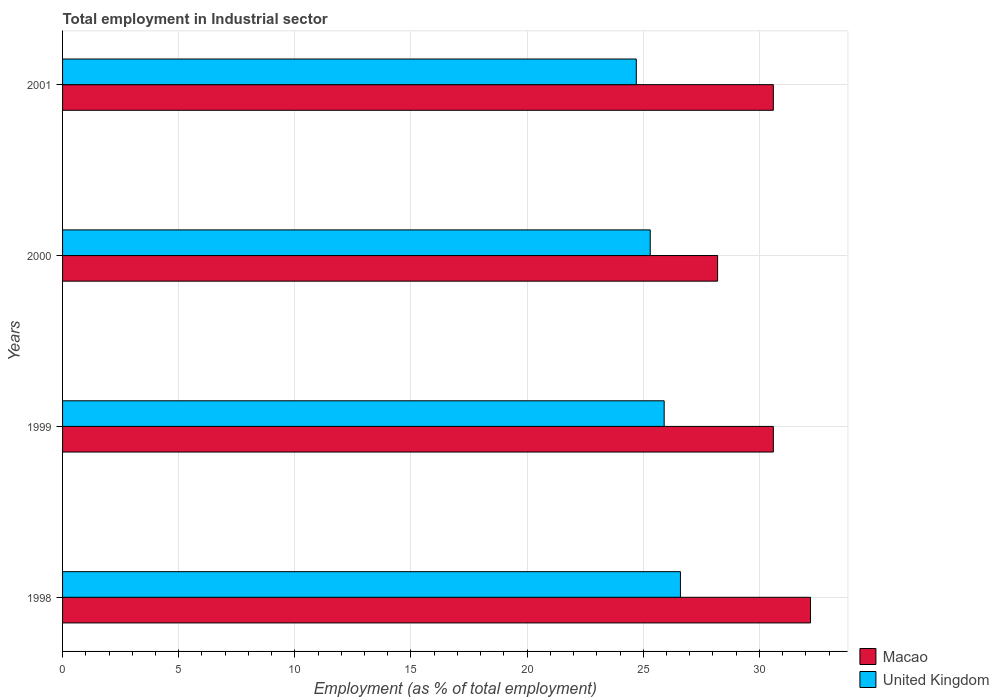Are the number of bars per tick equal to the number of legend labels?
Your answer should be compact. Yes. Are the number of bars on each tick of the Y-axis equal?
Provide a short and direct response. Yes. How many bars are there on the 1st tick from the top?
Your response must be concise. 2. What is the employment in industrial sector in United Kingdom in 1998?
Provide a short and direct response. 26.6. Across all years, what is the maximum employment in industrial sector in United Kingdom?
Your answer should be compact. 26.6. Across all years, what is the minimum employment in industrial sector in United Kingdom?
Your response must be concise. 24.7. In which year was the employment in industrial sector in United Kingdom minimum?
Ensure brevity in your answer.  2001. What is the total employment in industrial sector in United Kingdom in the graph?
Your answer should be very brief. 102.5. What is the difference between the employment in industrial sector in United Kingdom in 1998 and that in 2000?
Ensure brevity in your answer.  1.3. What is the average employment in industrial sector in United Kingdom per year?
Keep it short and to the point. 25.62. In the year 1998, what is the difference between the employment in industrial sector in Macao and employment in industrial sector in United Kingdom?
Keep it short and to the point. 5.6. In how many years, is the employment in industrial sector in Macao greater than 20 %?
Make the answer very short. 4. What is the ratio of the employment in industrial sector in Macao in 1999 to that in 2000?
Provide a short and direct response. 1.09. Is the difference between the employment in industrial sector in Macao in 2000 and 2001 greater than the difference between the employment in industrial sector in United Kingdom in 2000 and 2001?
Give a very brief answer. No. What is the difference between the highest and the second highest employment in industrial sector in United Kingdom?
Provide a short and direct response. 0.7. What is the difference between the highest and the lowest employment in industrial sector in Macao?
Give a very brief answer. 4. Is the sum of the employment in industrial sector in Macao in 1999 and 2001 greater than the maximum employment in industrial sector in United Kingdom across all years?
Ensure brevity in your answer.  Yes. What does the 1st bar from the top in 2001 represents?
Offer a very short reply. United Kingdom. What does the 1st bar from the bottom in 2000 represents?
Your answer should be very brief. Macao. How many bars are there?
Your answer should be very brief. 8. Are all the bars in the graph horizontal?
Offer a very short reply. Yes. What is the difference between two consecutive major ticks on the X-axis?
Offer a very short reply. 5. Are the values on the major ticks of X-axis written in scientific E-notation?
Offer a very short reply. No. What is the title of the graph?
Offer a very short reply. Total employment in Industrial sector. What is the label or title of the X-axis?
Provide a short and direct response. Employment (as % of total employment). What is the label or title of the Y-axis?
Provide a succinct answer. Years. What is the Employment (as % of total employment) of Macao in 1998?
Provide a short and direct response. 32.2. What is the Employment (as % of total employment) of United Kingdom in 1998?
Your answer should be very brief. 26.6. What is the Employment (as % of total employment) of Macao in 1999?
Give a very brief answer. 30.6. What is the Employment (as % of total employment) in United Kingdom in 1999?
Offer a terse response. 25.9. What is the Employment (as % of total employment) of Macao in 2000?
Provide a short and direct response. 28.2. What is the Employment (as % of total employment) in United Kingdom in 2000?
Keep it short and to the point. 25.3. What is the Employment (as % of total employment) in Macao in 2001?
Give a very brief answer. 30.6. What is the Employment (as % of total employment) in United Kingdom in 2001?
Give a very brief answer. 24.7. Across all years, what is the maximum Employment (as % of total employment) of Macao?
Your answer should be compact. 32.2. Across all years, what is the maximum Employment (as % of total employment) of United Kingdom?
Provide a short and direct response. 26.6. Across all years, what is the minimum Employment (as % of total employment) of Macao?
Your answer should be compact. 28.2. Across all years, what is the minimum Employment (as % of total employment) of United Kingdom?
Your response must be concise. 24.7. What is the total Employment (as % of total employment) of Macao in the graph?
Make the answer very short. 121.6. What is the total Employment (as % of total employment) of United Kingdom in the graph?
Your answer should be compact. 102.5. What is the difference between the Employment (as % of total employment) of United Kingdom in 1998 and that in 2000?
Offer a very short reply. 1.3. What is the difference between the Employment (as % of total employment) in Macao in 1999 and that in 2000?
Your response must be concise. 2.4. What is the difference between the Employment (as % of total employment) in Macao in 2000 and that in 2001?
Make the answer very short. -2.4. What is the difference between the Employment (as % of total employment) of Macao in 1998 and the Employment (as % of total employment) of United Kingdom in 2001?
Provide a succinct answer. 7.5. What is the difference between the Employment (as % of total employment) of Macao in 1999 and the Employment (as % of total employment) of United Kingdom in 2001?
Offer a very short reply. 5.9. What is the average Employment (as % of total employment) of Macao per year?
Make the answer very short. 30.4. What is the average Employment (as % of total employment) of United Kingdom per year?
Provide a short and direct response. 25.62. In the year 1998, what is the difference between the Employment (as % of total employment) of Macao and Employment (as % of total employment) of United Kingdom?
Provide a succinct answer. 5.6. In the year 1999, what is the difference between the Employment (as % of total employment) in Macao and Employment (as % of total employment) in United Kingdom?
Give a very brief answer. 4.7. In the year 2000, what is the difference between the Employment (as % of total employment) of Macao and Employment (as % of total employment) of United Kingdom?
Offer a terse response. 2.9. In the year 2001, what is the difference between the Employment (as % of total employment) of Macao and Employment (as % of total employment) of United Kingdom?
Your answer should be compact. 5.9. What is the ratio of the Employment (as % of total employment) in Macao in 1998 to that in 1999?
Keep it short and to the point. 1.05. What is the ratio of the Employment (as % of total employment) of Macao in 1998 to that in 2000?
Your response must be concise. 1.14. What is the ratio of the Employment (as % of total employment) of United Kingdom in 1998 to that in 2000?
Your answer should be very brief. 1.05. What is the ratio of the Employment (as % of total employment) in Macao in 1998 to that in 2001?
Your answer should be compact. 1.05. What is the ratio of the Employment (as % of total employment) of Macao in 1999 to that in 2000?
Your response must be concise. 1.09. What is the ratio of the Employment (as % of total employment) of United Kingdom in 1999 to that in 2000?
Ensure brevity in your answer.  1.02. What is the ratio of the Employment (as % of total employment) in Macao in 1999 to that in 2001?
Your answer should be very brief. 1. What is the ratio of the Employment (as % of total employment) in United Kingdom in 1999 to that in 2001?
Ensure brevity in your answer.  1.05. What is the ratio of the Employment (as % of total employment) in Macao in 2000 to that in 2001?
Ensure brevity in your answer.  0.92. What is the ratio of the Employment (as % of total employment) in United Kingdom in 2000 to that in 2001?
Your answer should be very brief. 1.02. What is the difference between the highest and the second highest Employment (as % of total employment) of Macao?
Your response must be concise. 1.6. What is the difference between the highest and the lowest Employment (as % of total employment) of Macao?
Make the answer very short. 4. 